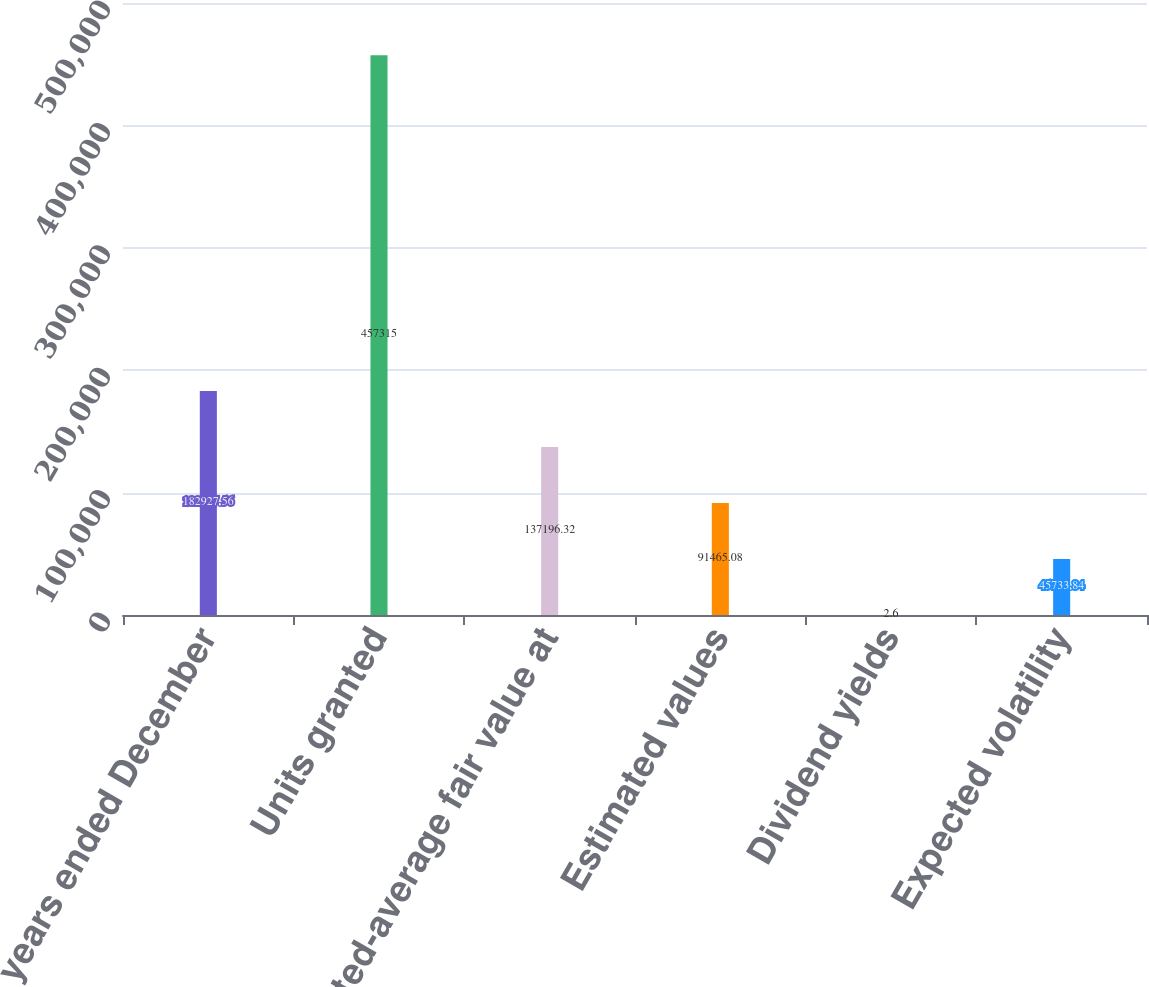<chart> <loc_0><loc_0><loc_500><loc_500><bar_chart><fcel>For the years ended December<fcel>Units granted<fcel>Weighted-average fair value at<fcel>Estimated values<fcel>Dividend yields<fcel>Expected volatility<nl><fcel>182928<fcel>457315<fcel>137196<fcel>91465.1<fcel>2.6<fcel>45733.8<nl></chart> 